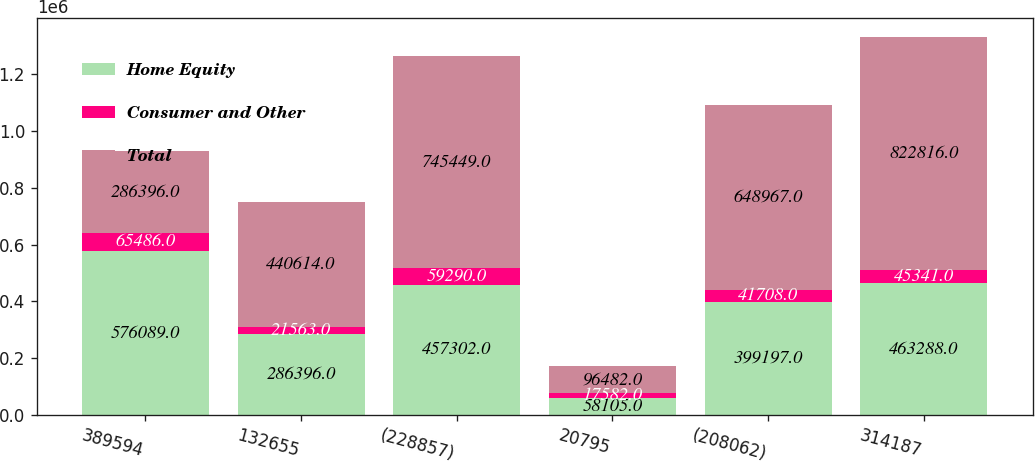<chart> <loc_0><loc_0><loc_500><loc_500><stacked_bar_chart><ecel><fcel>389594<fcel>132655<fcel>(228857)<fcel>20795<fcel>(208062)<fcel>314187<nl><fcel>Home Equity<fcel>576089<fcel>286396<fcel>457302<fcel>58105<fcel>399197<fcel>463288<nl><fcel>Consumer and Other<fcel>65486<fcel>21563<fcel>59290<fcel>17582<fcel>41708<fcel>45341<nl><fcel>Total<fcel>286396<fcel>440614<fcel>745449<fcel>96482<fcel>648967<fcel>822816<nl></chart> 